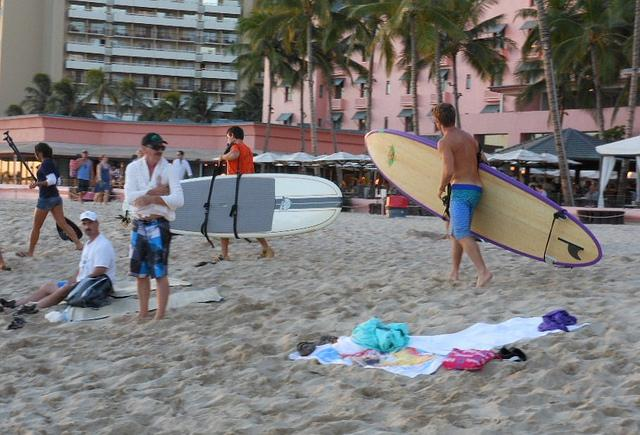What type of trees can be seen near the pink building? Please explain your reasoning. palm trees. The long thin nature of these trees' leaves and they're marked up wispy trunks identifies them as palm trees. 